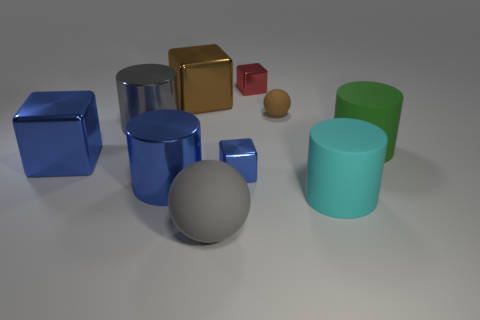What number of other brown rubber spheres are the same size as the brown sphere?
Offer a terse response. 0. What material is the red block?
Ensure brevity in your answer.  Metal. Is the number of big gray objects greater than the number of blue objects?
Ensure brevity in your answer.  No. Do the cyan thing and the large gray metallic thing have the same shape?
Offer a very short reply. Yes. Does the shiny cylinder behind the green matte object have the same color as the matte sphere to the left of the brown sphere?
Provide a short and direct response. Yes. Is the number of big gray rubber objects on the left side of the large gray metallic cylinder less than the number of big objects that are left of the green rubber object?
Your answer should be compact. Yes. There is a brown object that is to the left of the small rubber thing; what is its shape?
Your answer should be very brief. Cube. There is a big block that is the same color as the small ball; what material is it?
Your answer should be compact. Metal. How many other things are there of the same material as the big brown object?
Provide a succinct answer. 5. There is a gray metallic thing; does it have the same shape as the big rubber thing that is behind the blue cylinder?
Provide a succinct answer. Yes. 